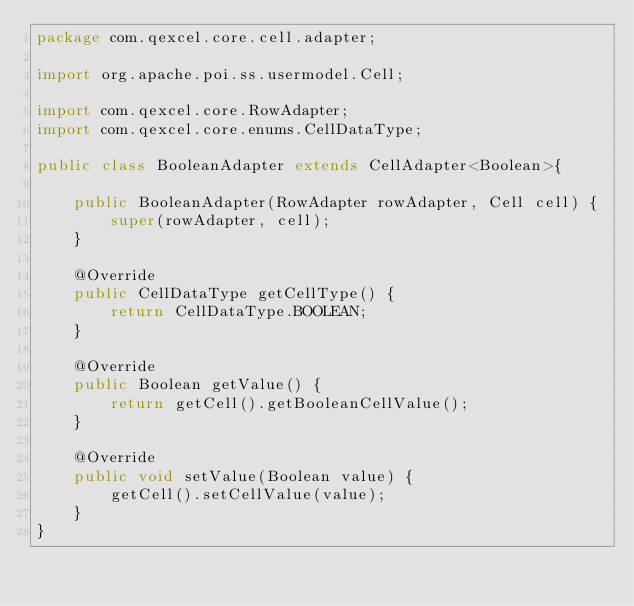Convert code to text. <code><loc_0><loc_0><loc_500><loc_500><_Java_>package com.qexcel.core.cell.adapter;

import org.apache.poi.ss.usermodel.Cell;

import com.qexcel.core.RowAdapter;
import com.qexcel.core.enums.CellDataType;

public class BooleanAdapter extends CellAdapter<Boolean>{

	public BooleanAdapter(RowAdapter rowAdapter, Cell cell) {
		super(rowAdapter, cell);
	}
	
	@Override
    public CellDataType getCellType() {
        return CellDataType.BOOLEAN;
    }

    @Override
    public Boolean getValue() {
        return getCell().getBooleanCellValue();
    }

    @Override
    public void setValue(Boolean value) {
        getCell().setCellValue(value);
    }
}
</code> 